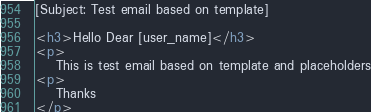Convert code to text. <code><loc_0><loc_0><loc_500><loc_500><_HTML_>[Subject: Test email based on template]

<h3>Hello Dear [user_name]</h3>
<p>
	This is test email based on template and placeholders
<p>
	Thanks
</p>
</code> 